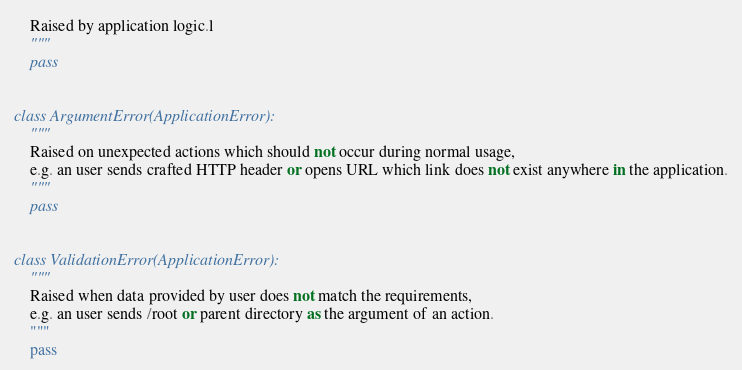Convert code to text. <code><loc_0><loc_0><loc_500><loc_500><_Python_>    Raised by application logic.l
    """
    pass


class ArgumentError(ApplicationError):
    """
    Raised on unexpected actions which should not occur during normal usage,
    e.g. an user sends crafted HTTP header or opens URL which link does not exist anywhere in the application.
    """
    pass


class ValidationError(ApplicationError):
    """
    Raised when data provided by user does not match the requirements,
    e.g. an user sends /root or parent directory as the argument of an action.
    """
    pass
</code> 